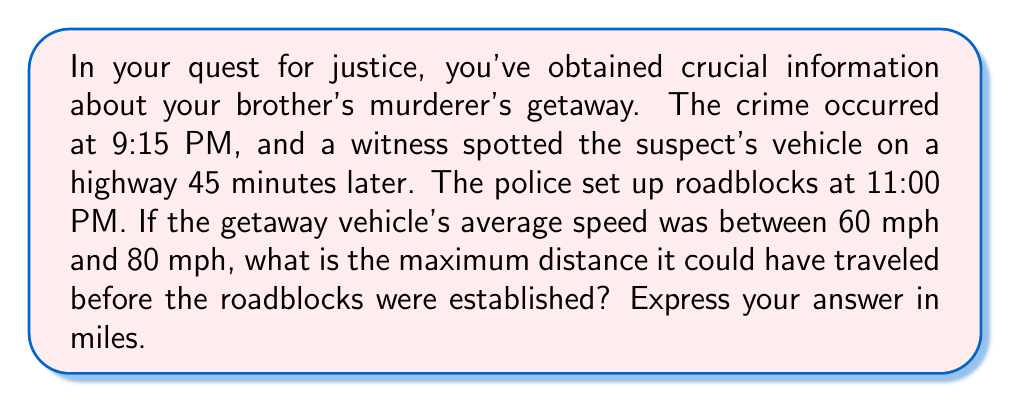Show me your answer to this math problem. Let's approach this step-by-step:

1) First, let's calculate the total time available for travel:
   - Crime occurred at 9:15 PM
   - Roadblocks set up at 11:00 PM
   Total time = 11:00 PM - 9:15 PM = 1 hour and 45 minutes = 1.75 hours

2) We're given that the vehicle was spotted 45 minutes after the crime. This means:
   - Time from crime to spotting: 45 minutes = 0.75 hours
   - Remaining time after spotting: 1.75 - 0.75 = 1 hour

3) We need to find the maximum distance, which will occur at the highest possible speed. The highest speed given is 80 mph.

4) To calculate the maximum distance, we use the formula:
   $$\text{Distance} = \text{Speed} \times \text{Time}$$

5) For the first 45 minutes (0.75 hours):
   $$\text{Distance}_1 = 80 \text{ mph} \times 0.75 \text{ h} = 60 \text{ miles}$$

6) For the remaining 1 hour:
   $$\text{Distance}_2 = 80 \text{ mph} \times 1 \text{ h} = 80 \text{ miles}$$

7) Total maximum distance:
   $$\text{Total Distance} = \text{Distance}_1 + \text{Distance}_2 = 60 + 80 = 140 \text{ miles}$$

Therefore, the maximum distance the getaway vehicle could have traveled is 140 miles.
Answer: 140 miles 